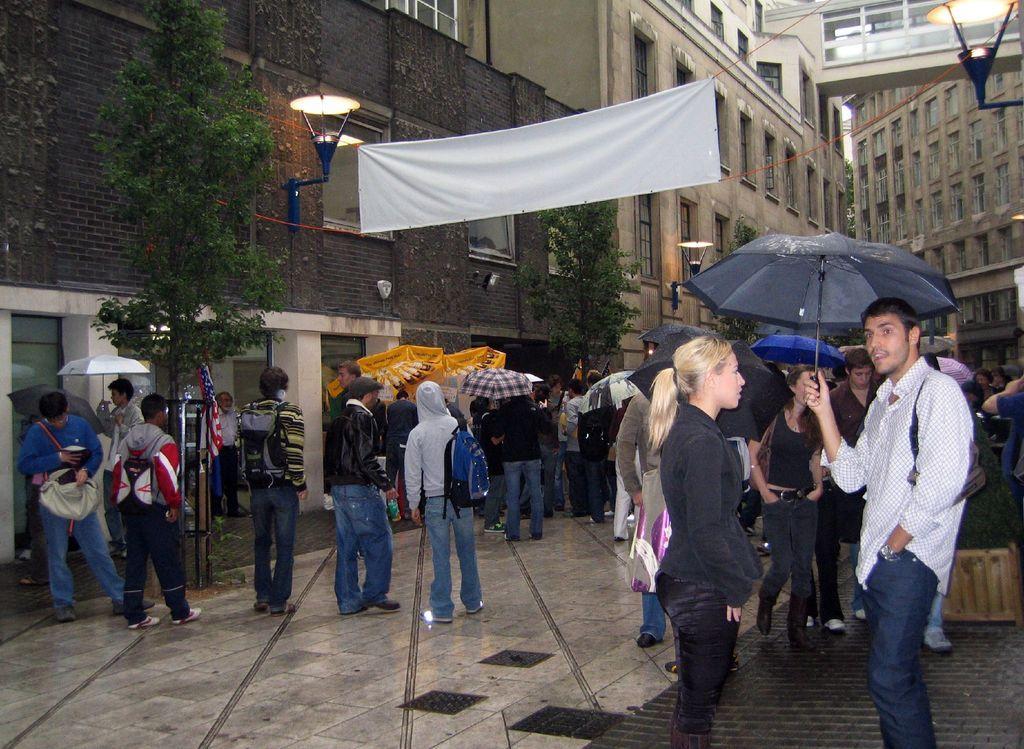Could you give a brief overview of what you see in this image? In this image we can see the buildings, trees, lights and also the white color banner with the ropes. We can also see the people standing on the path and a few are holding the umbrellas. 